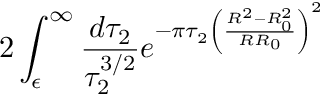Convert formula to latex. <formula><loc_0><loc_0><loc_500><loc_500>2 \int _ { \epsilon } ^ { \infty } \frac { d \tau _ { 2 } } { \tau _ { 2 } ^ { 3 / 2 } } e ^ { - \pi \tau _ { 2 } \left ( \frac { R ^ { 2 } - R _ { 0 } ^ { 2 } } { R R _ { 0 } } \right ) ^ { 2 } }</formula> 